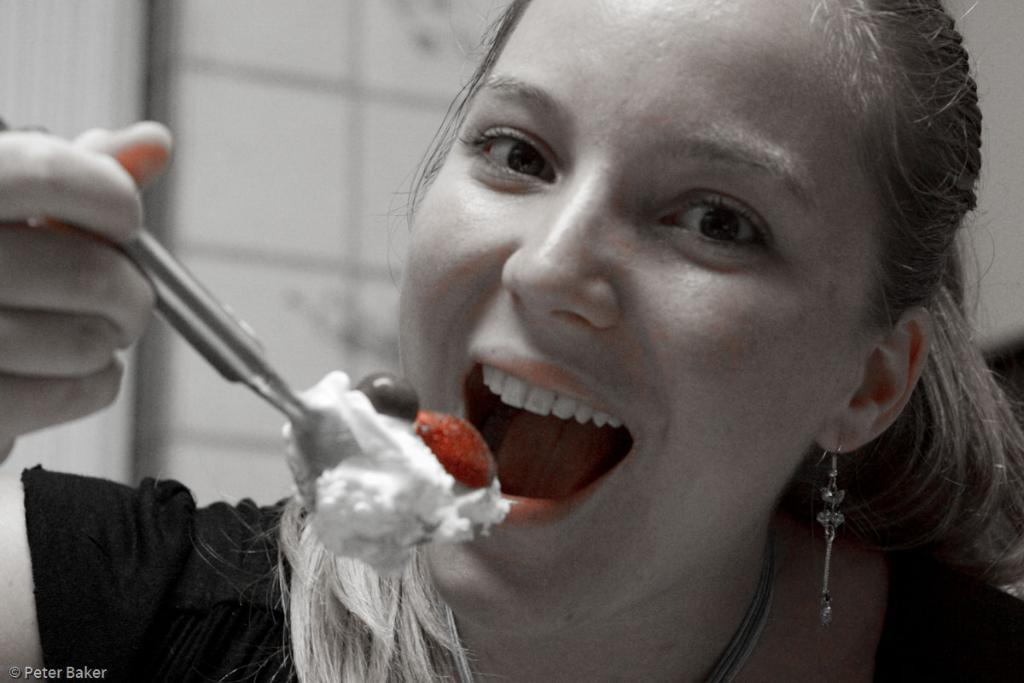Who is present in the image? There is a woman in the image. What is the woman holding in the image? The woman is holding a spoon. What is on the spoon that the woman is holding? There is a food item on the spoon. Can you read any text in the image? Yes, there is text visible in the bottom left corner of the image. What type of punishment is the woman receiving in the image? There is no indication in the image that the woman is receiving any punishment. Can you hear the drum in the image? There is no drum present in the image, so it cannot be heard. 